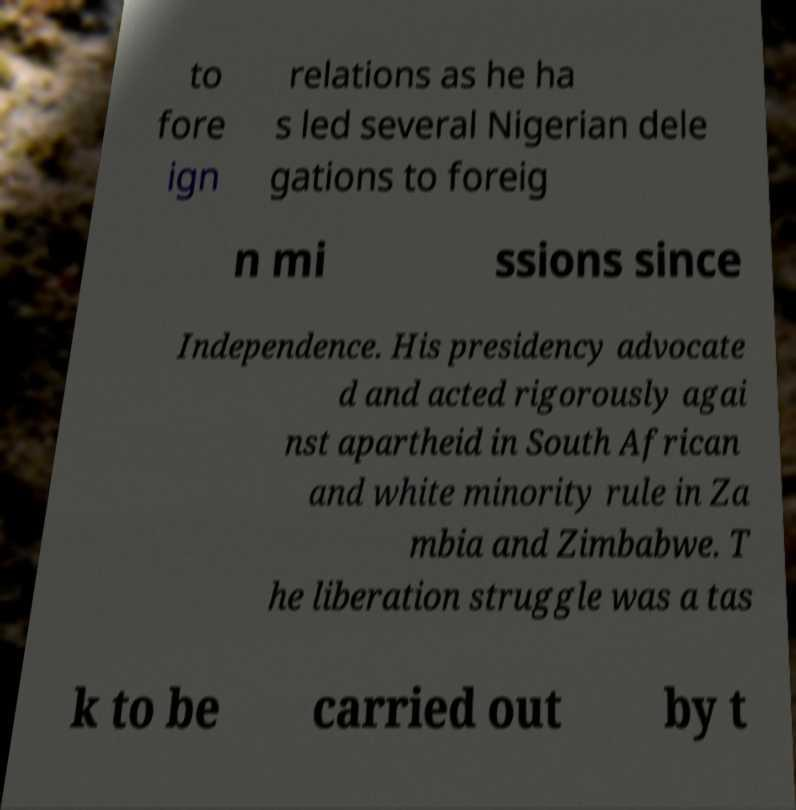Please read and relay the text visible in this image. What does it say? to fore ign relations as he ha s led several Nigerian dele gations to foreig n mi ssions since Independence. His presidency advocate d and acted rigorously agai nst apartheid in South African and white minority rule in Za mbia and Zimbabwe. T he liberation struggle was a tas k to be carried out by t 